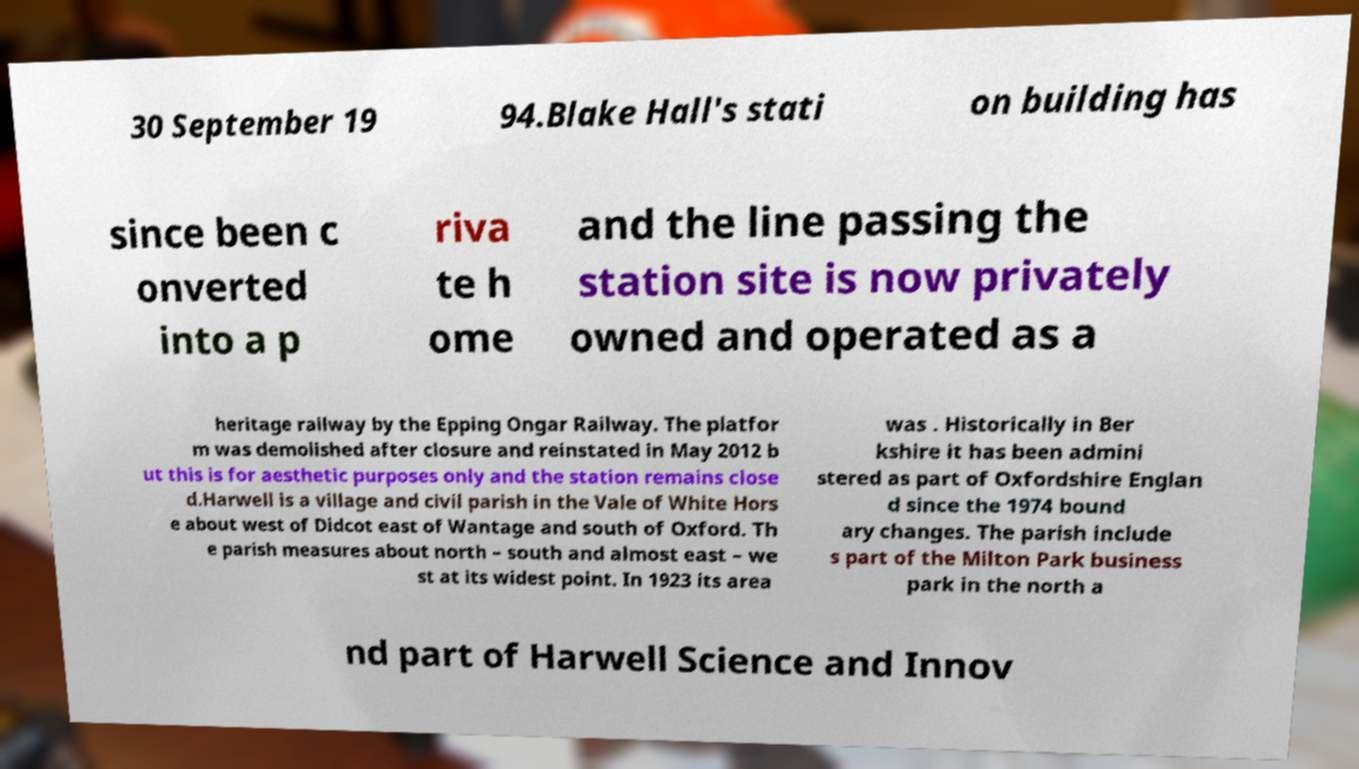What messages or text are displayed in this image? I need them in a readable, typed format. 30 September 19 94.Blake Hall's stati on building has since been c onverted into a p riva te h ome and the line passing the station site is now privately owned and operated as a heritage railway by the Epping Ongar Railway. The platfor m was demolished after closure and reinstated in May 2012 b ut this is for aesthetic purposes only and the station remains close d.Harwell is a village and civil parish in the Vale of White Hors e about west of Didcot east of Wantage and south of Oxford. Th e parish measures about north – south and almost east – we st at its widest point. In 1923 its area was . Historically in Ber kshire it has been admini stered as part of Oxfordshire Englan d since the 1974 bound ary changes. The parish include s part of the Milton Park business park in the north a nd part of Harwell Science and Innov 